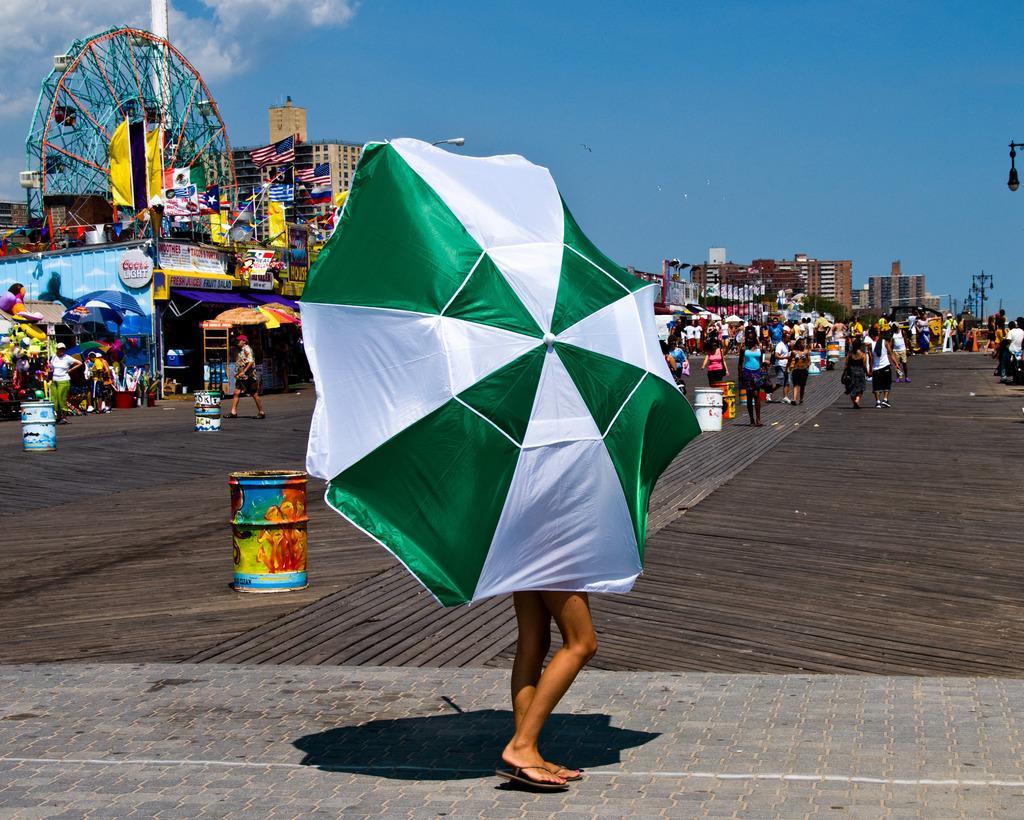How would you summarize this image in a sentence or two? In this picture we can see a person's legs on the ground, here we can see an umbrella and in the background we can see we can see a group of people, barrels, giant wheel, flags, buildings, sky and few objects. 